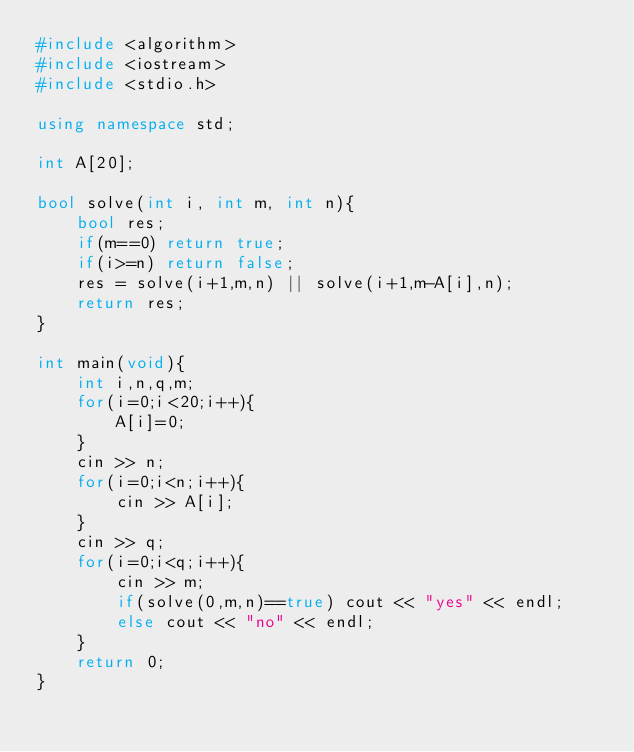Convert code to text. <code><loc_0><loc_0><loc_500><loc_500><_C++_>#include <algorithm>
#include <iostream>
#include <stdio.h>

using namespace std;

int A[20];

bool solve(int i, int m, int n){
    bool res;
    if(m==0) return true;
    if(i>=n) return false;
    res = solve(i+1,m,n) || solve(i+1,m-A[i],n);
    return res;
}

int main(void){
    int i,n,q,m;
    for(i=0;i<20;i++){
        A[i]=0;
    }
    cin >> n;
    for(i=0;i<n;i++){
        cin >> A[i];
    }
    cin >> q;
    for(i=0;i<q;i++){
        cin >> m;
        if(solve(0,m,n)==true) cout << "yes" << endl;
        else cout << "no" << endl;
    }
    return 0;
}</code> 